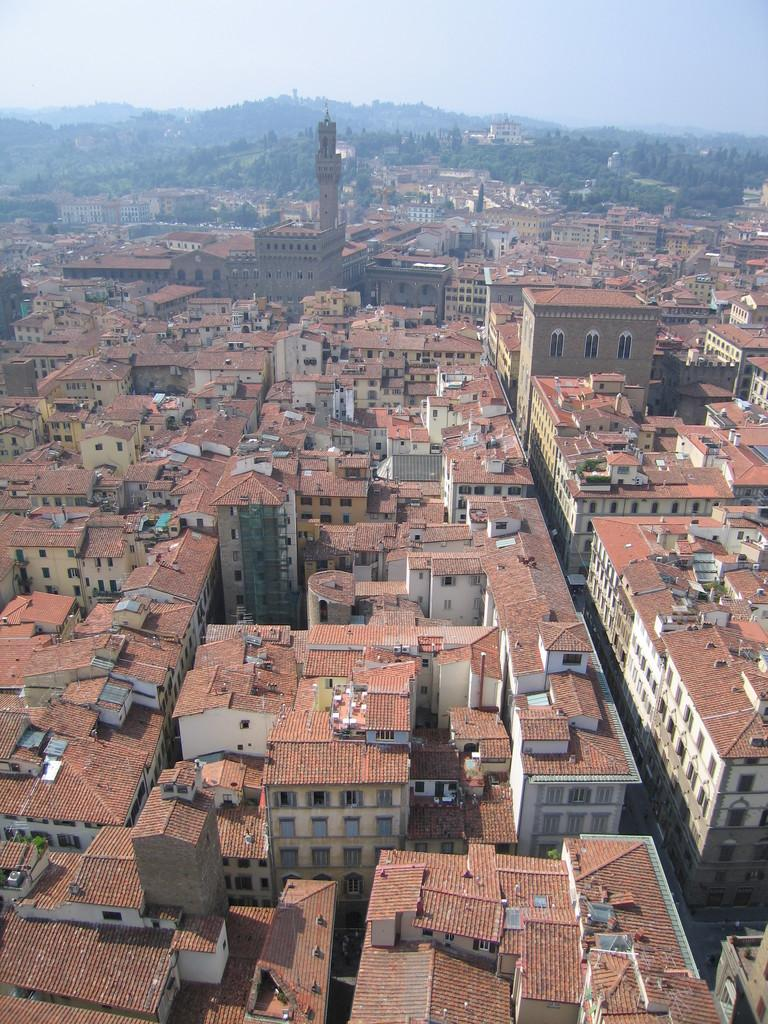What type of view is shown in the image? The image is a top view of a city. What can be seen in the center of the image? There are buildings in the center of the image. What is visible in the background of the image? There is sky and mountains visible in the background of the image. Can you see any rays of sunlight shining through the stocking in the image? There is no stocking or rays of sunlight present in the image. 